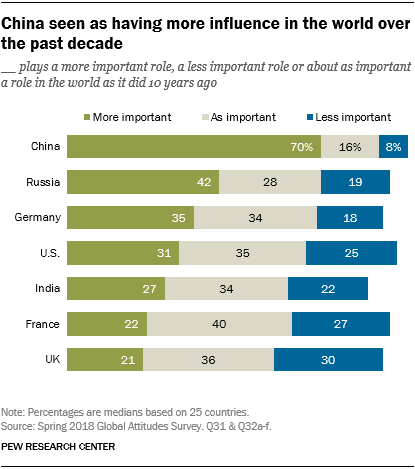Specify some key components in this picture. According to a recent survey, a significant percentage of people believe that India is playing a more important role in the world today compared to 10 years ago, with 0.61 being the exact percentage. According to a recent survey, a small percentage of people, approximately 0.22%, believe that France is currently playing a more significant role in the world compared to 10 years ago. 